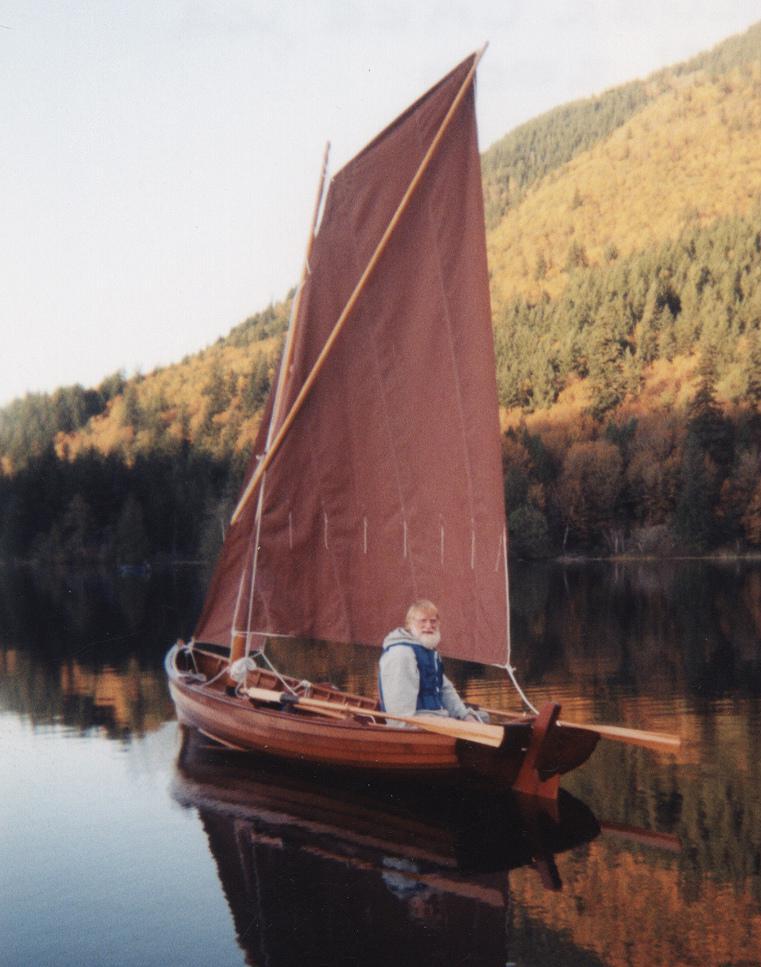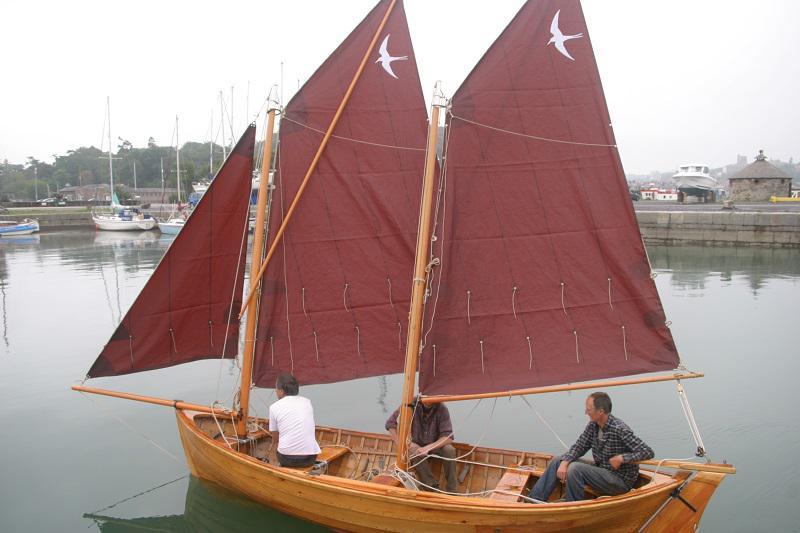The first image is the image on the left, the second image is the image on the right. For the images displayed, is the sentence "At least three people sit in boats with red sails." factually correct? Answer yes or no. Yes. The first image is the image on the left, the second image is the image on the right. For the images shown, is this caption "There is at least three humans riding in a sailboat." true? Answer yes or no. Yes. 